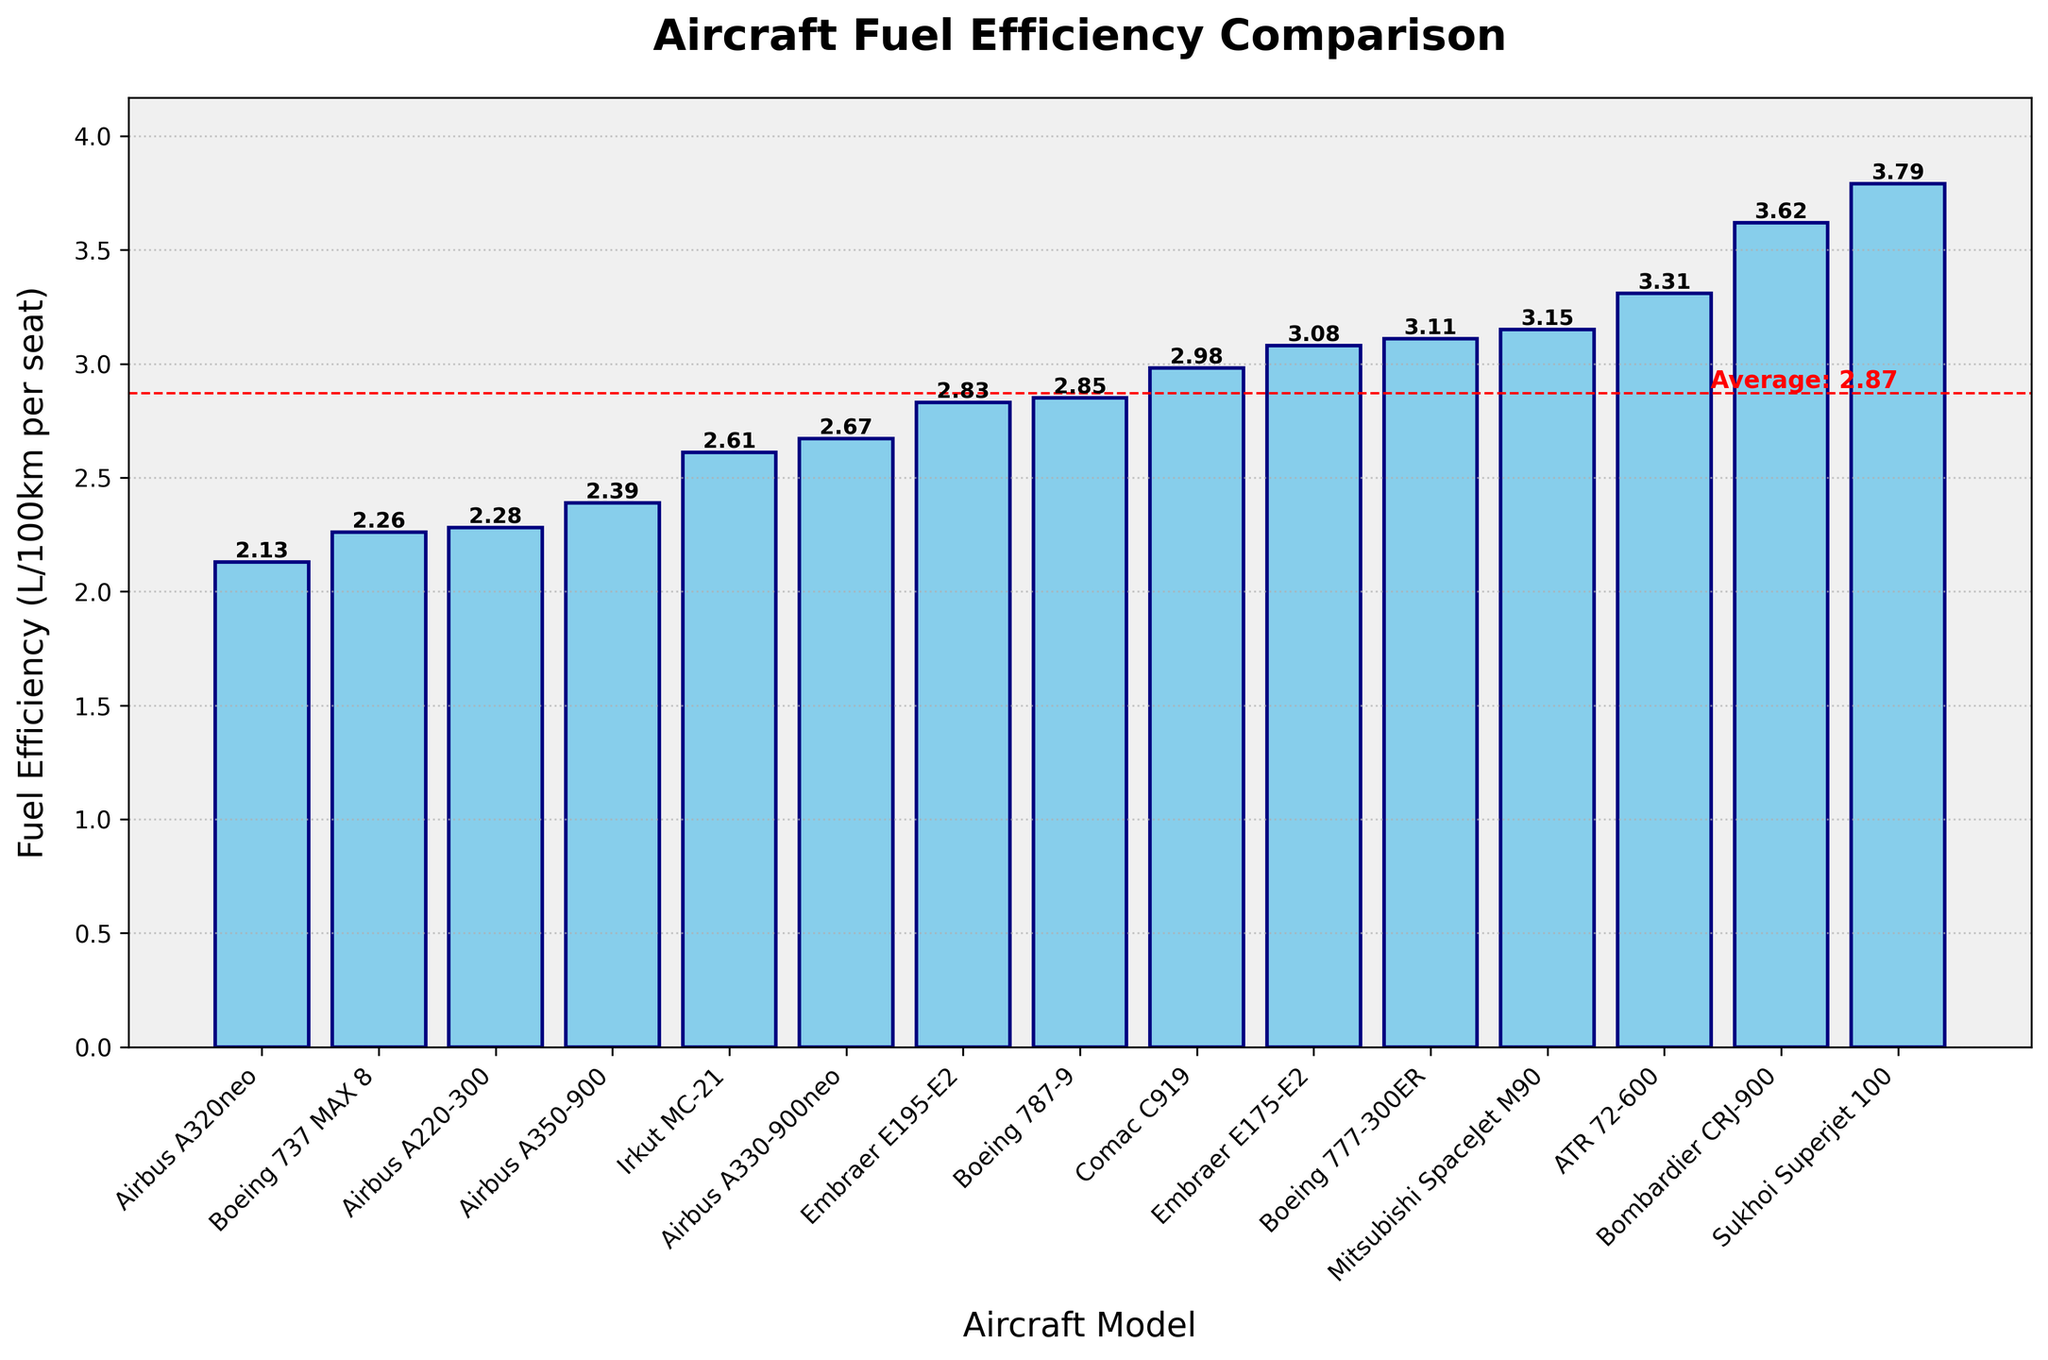What is the fuel efficiency of the Boeing 787-9? Identify the bar corresponding to Boeing 787-9 and read its height, which is labeled with the value.
Answer: 2.85 Which aircraft model has the highest fuel efficiency? Identify the bar with the lowest height, as lower values indicate higher efficiency. The corresponding label is Airbus A320neo.
Answer: Airbus A320neo Which aircraft model has the lowest fuel efficiency? Identify the bar with the highest height, as higher values indicate lower efficiency. The corresponding label is Sukhoi Superjet 100.
Answer: Sukhoi Superjet 100 What is the average fuel efficiency of the aircraft models shown? Look for the red dashed horizontal line labeled "Average" and read the value.
Answer: 2.85 How does the fuel efficiency of the Airbus A220-300 compare to that of the Boeing 737 MAX 8? Identify the bars for Airbus A220-300 and Boeing 737 MAX 8, and compare their heights. Airbus A220-300 is slightly lower, thus more fuel efficient.
Answer: Airbus A220-300 is more efficient By how much does the fuel efficiency of the ATR 72-600 differ from that of the Bombardier CRJ-900? Identify the bars for ATR 72-600 (3.31) and Bombardier CRJ-900 (3.62), and calculate the absolute difference:
Answer: 0.31 What is the combined fuel efficiency of the two least efficient aircraft models (Bombardier CRJ-900 and Sukhoi Superjet 100)? Identify the bar heights for Bombardier CRJ-900 (3.62) and Sukhoi Superjet 100 (3.79), and sum them: 3.62 + 3.79 = 7.41.
Answer: 7.41 Which aircraft model is closest to the average fuel efficiency value? Identify the average value (red dashed line) and find the bar whose height is closest. This aligns Im-hop's FEF model with Boeing 787-9 ( with a value of 2.85).
Answer: Boeing 787-9 Is the Boeing 777-300ER above or below the average fuel efficiency? Identify the bar for Boeing 777-300ER and the average line. Boeing 777-300ER’s height (3.11) is above the red dashed line (2.85).
Answer: Above What is the ratio of the fuel efficiency of the Embraer E195-E2 to that of the Embraer E175-E2? Identify the bar heights for Embraer E195-E2 (2.83) and Embraer E175-E2 (3.08), and calculate the ratio: 2.83 / 3.08 ≈ 0.92.
Answer: 0.92 